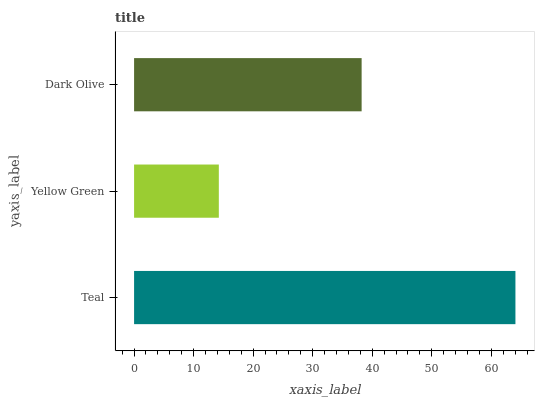Is Yellow Green the minimum?
Answer yes or no. Yes. Is Teal the maximum?
Answer yes or no. Yes. Is Dark Olive the minimum?
Answer yes or no. No. Is Dark Olive the maximum?
Answer yes or no. No. Is Dark Olive greater than Yellow Green?
Answer yes or no. Yes. Is Yellow Green less than Dark Olive?
Answer yes or no. Yes. Is Yellow Green greater than Dark Olive?
Answer yes or no. No. Is Dark Olive less than Yellow Green?
Answer yes or no. No. Is Dark Olive the high median?
Answer yes or no. Yes. Is Dark Olive the low median?
Answer yes or no. Yes. Is Yellow Green the high median?
Answer yes or no. No. Is Teal the low median?
Answer yes or no. No. 